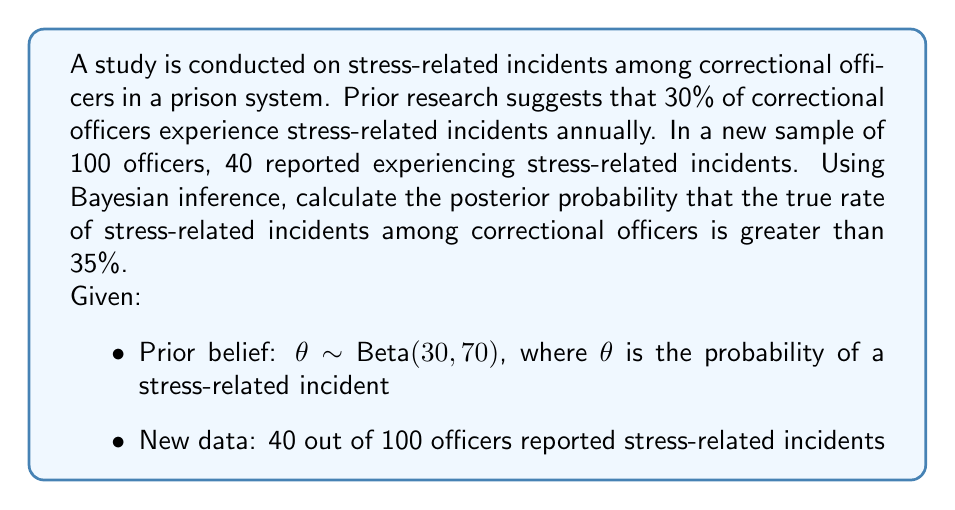Help me with this question. To solve this problem using Bayesian inference, we'll follow these steps:

1) First, we need to update our prior belief with the new data to get the posterior distribution.

2) The prior is given as Beta(30, 70), and we observed 40 successes out of 100 trials.

3) The posterior distribution will also be a Beta distribution, with parameters:
   $\alpha_{posterior} = \alpha_{prior} + \text{successes} = 30 + 40 = 70$
   $\beta_{posterior} = \beta_{prior} + \text{failures} = 70 + 60 = 130$

4) So, our posterior distribution is Beta(70, 130).

5) Now, we need to calculate P($\theta > 0.35$ | data), which is equivalent to 1 - P($\theta \leq 0.35$ | data).

6) For a Beta(a,b) distribution, the cumulative distribution function is given by the regularized incomplete beta function:

   $$P(\theta \leq x) = I_x(a,b) = \frac{B(x;a,b)}{B(a,b)}$$

   where B(x;a,b) is the incomplete beta function and B(a,b) is the beta function.

7) We need to calculate:

   $$1 - I_{0.35}(70,130)$$

8) This can be computed using statistical software or numerical integration. Using a computational tool, we get:

   $$1 - I_{0.35}(70,130) \approx 0.0432$$

Therefore, the posterior probability that the true rate of stress-related incidents among correctional officers is greater than 35% is approximately 0.0432 or 4.32%.
Answer: 0.0432 (or 4.32%) 